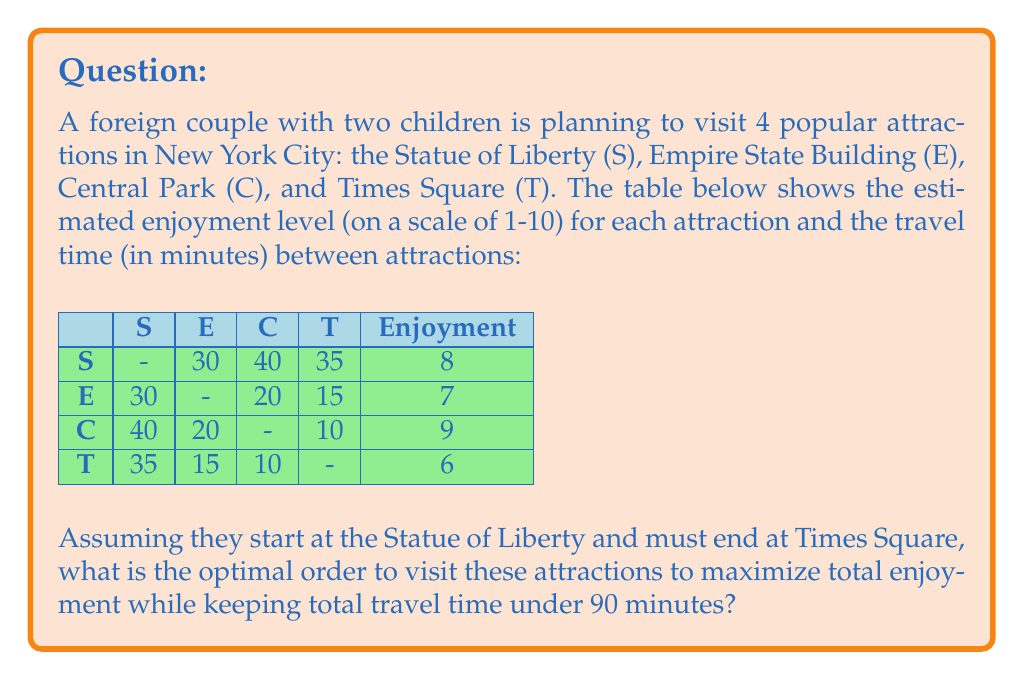Could you help me with this problem? Let's approach this step-by-step using dynamic programming:

1) First, we need to identify all possible routes that start at S and end at T, visiting E and C in between. There are two such routes:
   S → E → C → T
   S → C → E → T

2) Let's calculate the total travel time and enjoyment for each route:

   S → E → C → T:
   Travel time: 30 + 20 + 10 = 60 minutes
   Enjoyment: 8 + 7 + 9 + 6 = 30

   S → C → E → T:
   Travel time: 40 + 20 + 15 = 75 minutes
   Enjoyment: 8 + 9 + 7 + 6 = 30

3) Both routes have the same total enjoyment, but S → E → C → T has a shorter travel time.

4) We can express this as an optimization problem:

   Maximize: $E = e_S + e_E + e_C + e_T$
   Subject to: $t_{SE} + t_{EC} + t_{CT} \leq 90$

   Where $e_i$ is the enjoyment of attraction $i$, and $t_{ij}$ is the travel time from $i$ to $j$.

5) In this case, both routes satisfy the time constraint and have the same enjoyment level. However, the route S → E → C → T is optimal as it minimizes travel time while maximizing enjoyment.
Answer: S → E → C → T 